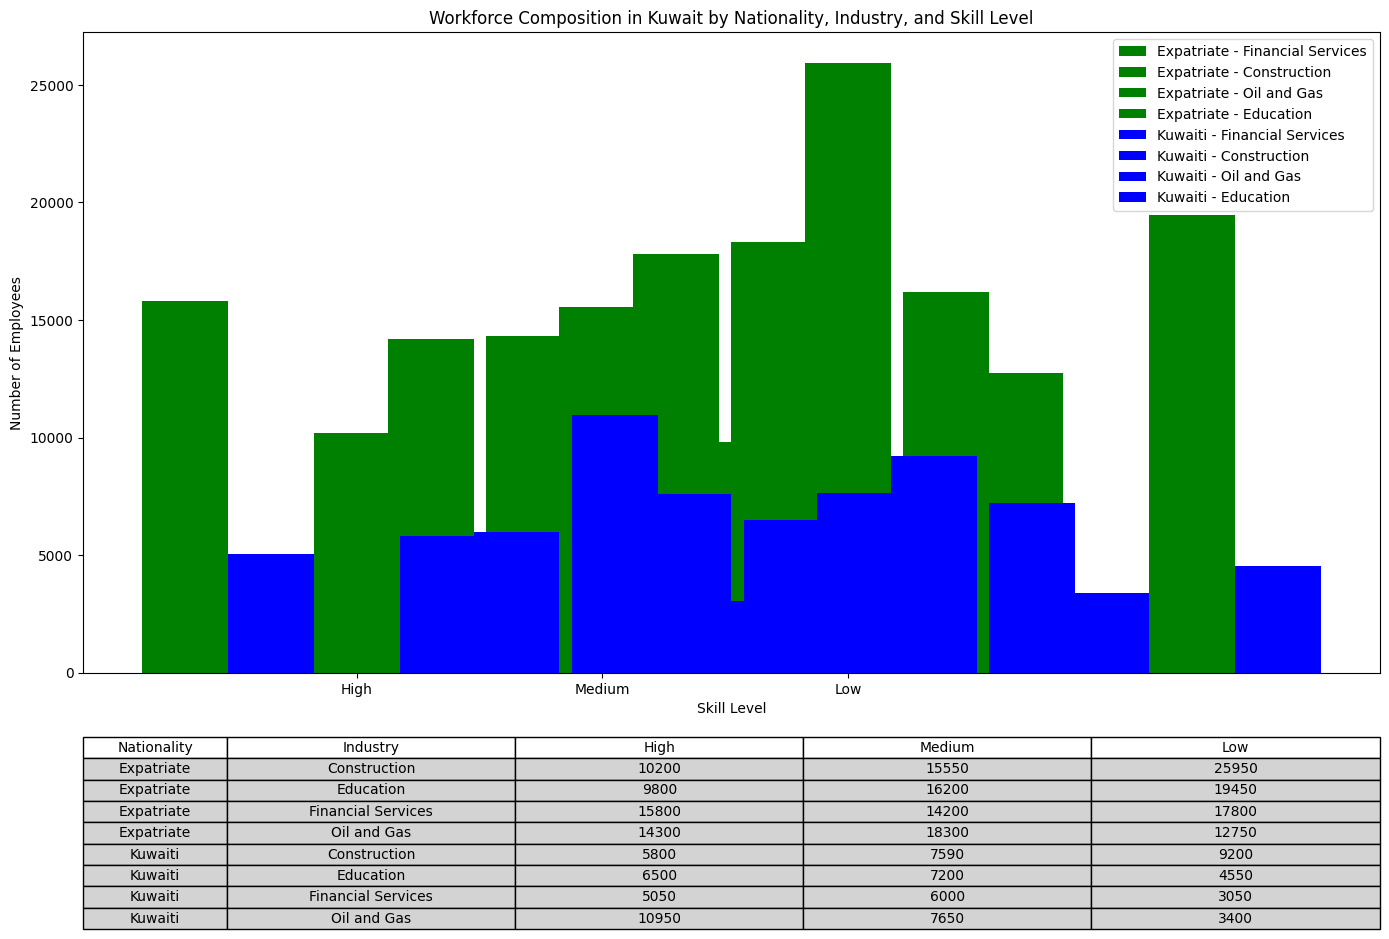Which nationality has a higher number of high-skill workers in the Oil and Gas industry? To determine which nationality has more high-skill workers in the Oil and Gas industry, compare the height of the bars representing "High" skill level for Kuwaiti and Expatriate in the Oil and Gas category. The bars suggest that Kuwaitis have 10,950 workers and Expatriates have 14,300 workers. Therefore, Expatriates have more high-skill workers in this industry.
Answer: Expatriates What is the total number of employees in the Education industry across all skill levels for Kuwaitis? Sum the number of high, medium, and low-skill employees in the Education industry for Kuwaitis from the table or bars: 6,500 (High) + 7,200 (Medium) + 4,550 (Low) = 18,250 employees.
Answer: 18,250 Which industry among Expatriates has the highest number of low-skill workers? Compare the height of the bars representing "Low" skill level for all industries among Expatriates. The "Construction" industry has the highest bar at 25,950 workers.
Answer: Construction In the Financial Services industry, how do the numbers of medium-skill employees compare between Kuwaitis and Expatriates? Look at the bars representing "Medium" skill level in the Financial Services industry for both nationalities. Kuwaitis have 6,000 employees, while Expatriates have 14,200 employees, showing that Expatriates have more medium-skill employees.
Answer: Expatriates have more What is the average number of high-skill employees in the Construction industry for both nationalities combined? Add the number of high-skill employees for both Kuwaitis and Expatriates in Construction, then divide by 2: (5,800 (Kuwaiti) + 10,200 (Expatriate)) / 2 = 16,000 / 2 = 8,000.
Answer: 8,000 Which nationality has a more balanced distribution across the skill levels in the Oil and Gas industry? Compare the differences in the number of employees across skill levels within the Oil and Gas industry for both nationalities. Kuwaitis have 10,950 (High), 7,650 (Medium), and 3,400 (Low) employees. Expatriates have 14,300 (High), 18,300 (Medium), and 12,750 (Low). Expatriates show less variation among skill levels, making their distribution more balanced.
Answer: Expatriates How many more low-skill workers are there in the Construction industry compared to the Education industry for Expatriates? Subtract the number of low-skill employees in the Education industry from the Construction industry for Expatriates: 25,950 (Construction) - 19,450 (Education) = 6,500.
Answer: 6,500 What is the difference in the total number of employees between Expatriates and Kuwaitis in all industries combined? Sum the total number of employees for both nationalities and then subtract: Total Expatriates = 15,800 + 14,200 + 17,800 + 10,200 + 15,550 + 25,950 + 14,300 + 18,300 + 12,750 + 9,800 + 16,200 + 19,450 = 189,300. Total Kuwaitis = 5,050 + 6,000 + 3,050 + 5,800 + 7,590 + 9,200 + 10,950 + 7,650 + 3,400 + 6,500 + 7,200 + 4,550 = 76,940. Difference = 189,300 - 76,940 = 112,360.
Answer: 112,360 